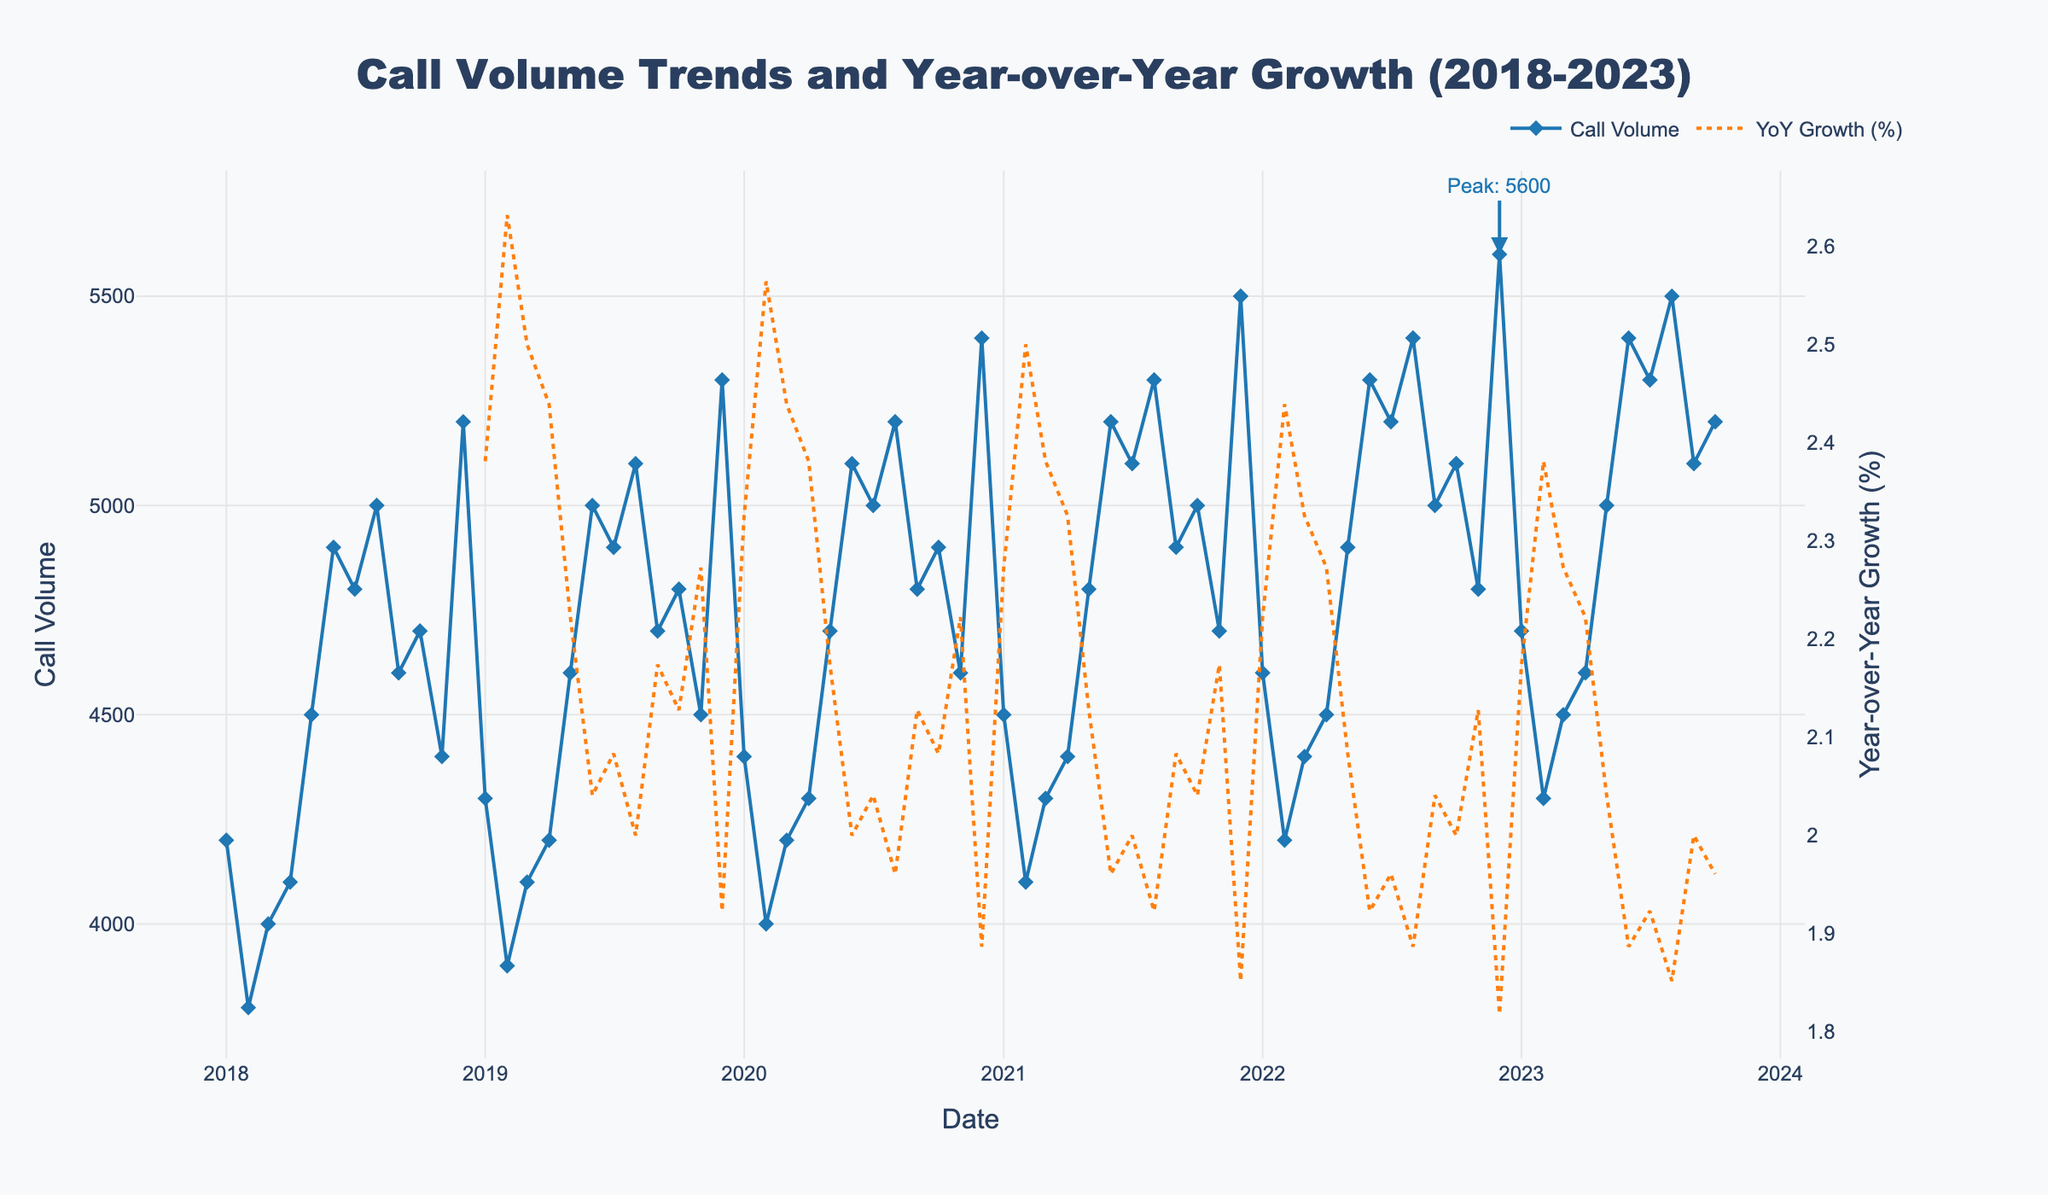What is the title of the figure? The title is located at the top of the figure and is formatted to be prominent and easily readable.
Answer: Call Volume Trends and Year-over-Year Growth (2018-2023) What is the highest call volume recorded, and in which month and year did it occur? The figure includes an annotation pointing out the peak call volume on the trend line.
Answer: 5600, December 2022 What is the call volume for January 2021? Find the point on the graph corresponding to January 2021 along the Date axis and check its Call Volume value.
Answer: 4500 During which year did the call center experience the highest year-over-year growth rate, and what was the approximate percentage? By observing the secondary y-axis depicting the year-over-year growth with a dotted orange line, find the year where the growth rate peaks.
Answer: 2021, about 10% Compare the call volumes of the months with the highest and lowest recorded values. What’s the difference in call volume between these two months? Identify the highest call volume (5600 in December 2022) and the lowest call volume (3800 in February 2018), then calculate the difference.
Answer: 5600 - 3800 = 1800 How does the call volume in July 2020 compare to the call volume in July 2018? Check the call volume values for both dates from the trend line.
Answer: 5000 in July 2020, 4800 in July 2018 Which month typically has the highest call volume each year, and how can you tell? Check for any recurring month that consistently shows high call volumes across the years. Observe the trend lines and peaks.
Answer: December What general trend can you observe about the call volumes from 2018 to 2023? Look at the general direction and pattern of the blue trend line over the entire period.
Answer: Increasing trend How often do call volumes peak in December throughout the years? Identify the number of times December has the highest call volume in each year from the trend line.
Answer: Every year 